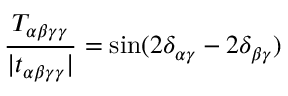Convert formula to latex. <formula><loc_0><loc_0><loc_500><loc_500>\frac { T _ { \alpha \beta \gamma \gamma } } { | t _ { \alpha \beta \gamma \gamma } | } = \sin ( 2 \delta _ { \alpha \gamma } - 2 \delta _ { \beta \gamma } )</formula> 